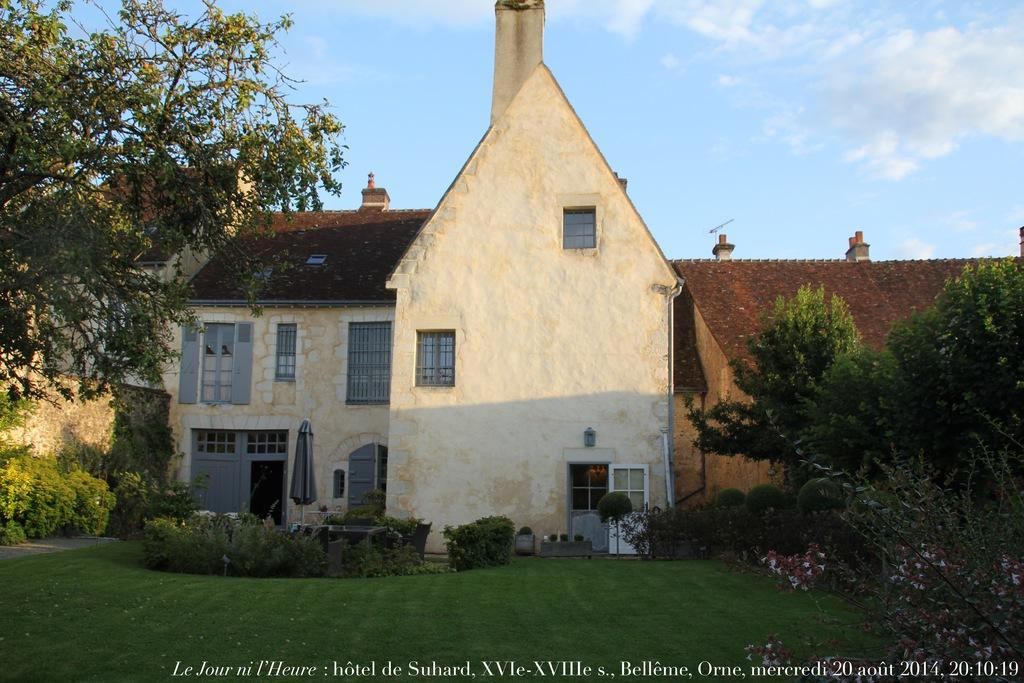What can be found at the bottom of the image? There is text at the bottom of the image. What type of vegetation is in the middle of the image? There are trees and bushes in the middle of the image. What type of structures are in the middle of the image? There are houses in the middle of the image. What is visible at the top of the image? The sky is visible at the top of the image. Where are the shoes located in the image? There are no shoes present in the image. What type of mine is depicted in the image? There is no mine present in the image. 